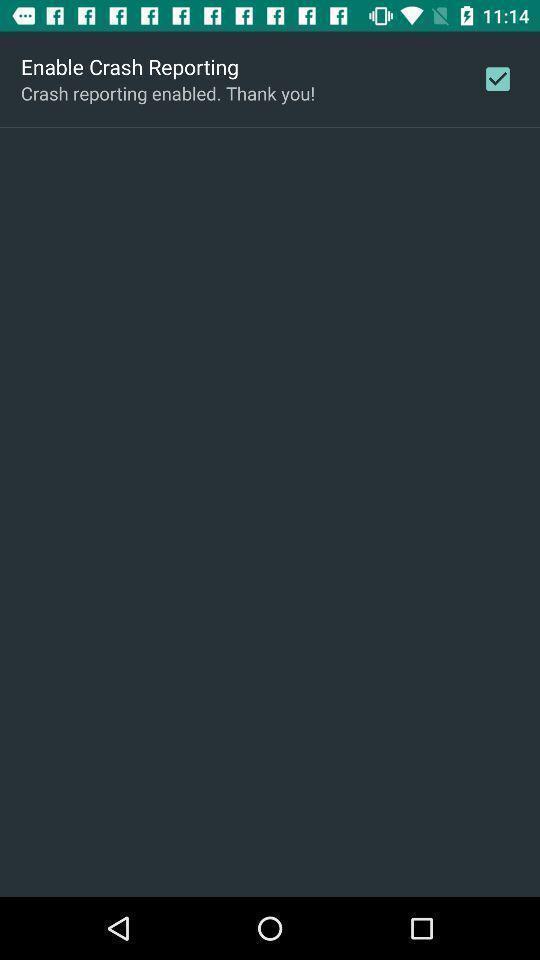Tell me what you see in this picture. Screen shows option to enable crash reporting. 